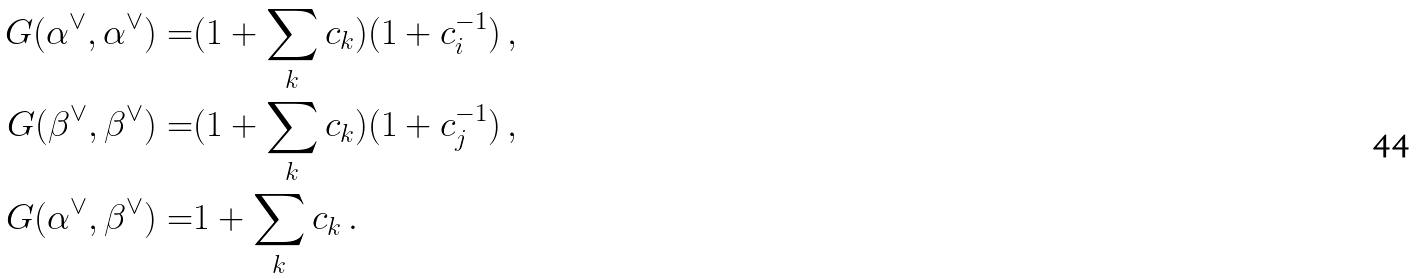<formula> <loc_0><loc_0><loc_500><loc_500>G ( \alpha ^ { \vee } , \alpha ^ { \vee } ) = & ( 1 + \sum _ { k } c _ { k } ) ( 1 + c _ { i } ^ { - 1 } ) \, , \\ G ( \beta ^ { \vee } , \beta ^ { \vee } ) = & ( 1 + \sum _ { k } c _ { k } ) ( 1 + c _ { j } ^ { - 1 } ) \, , \\ G ( \alpha ^ { \vee } , \beta ^ { \vee } ) = & 1 + \sum _ { k } c _ { k } \, .</formula> 